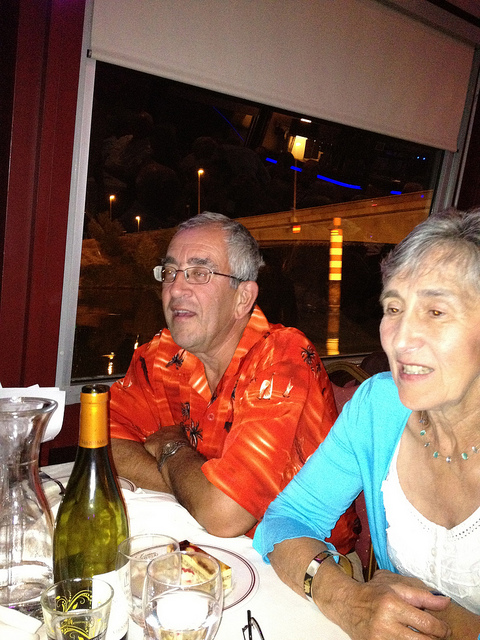Please provide the bounding box coordinate of the region this sentence describes: man in orange. The bounding box coordinates for the region describing the man in the orange shirt are approximately [0.29, 0.32, 0.66, 0.85]. 